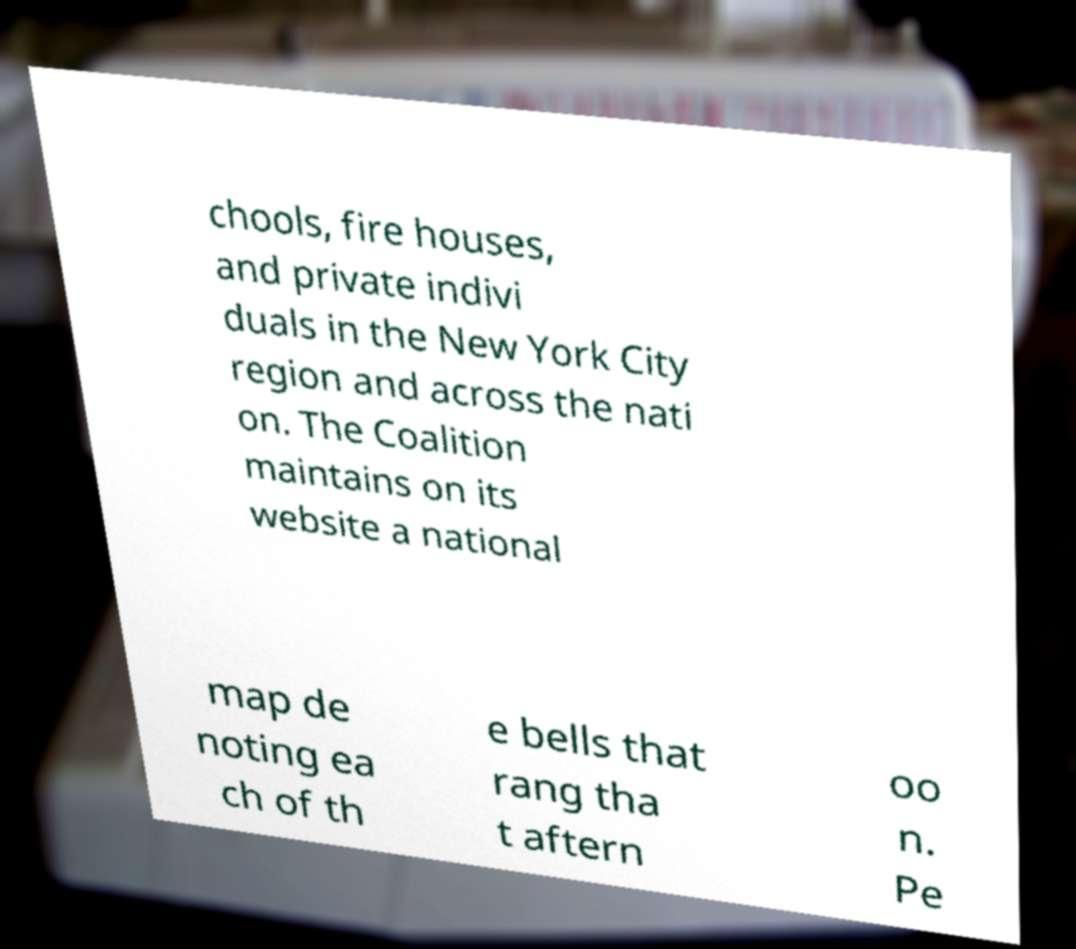Can you read and provide the text displayed in the image?This photo seems to have some interesting text. Can you extract and type it out for me? chools, fire houses, and private indivi duals in the New York City region and across the nati on. The Coalition maintains on its website a national map de noting ea ch of th e bells that rang tha t aftern oo n. Pe 